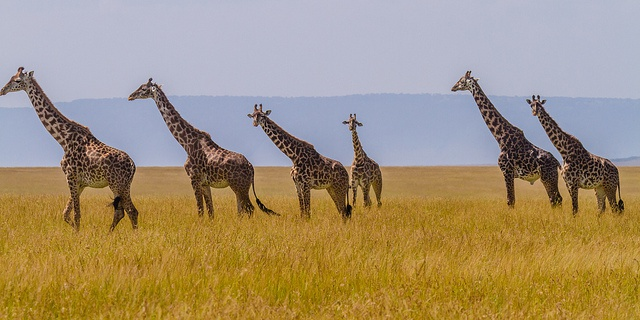Describe the objects in this image and their specific colors. I can see giraffe in lavender, black, maroon, and gray tones, giraffe in lightgray, black, maroon, and gray tones, giraffe in lavender, black, maroon, and gray tones, giraffe in lightgray, black, maroon, and gray tones, and giraffe in lavender, black, maroon, and gray tones in this image. 